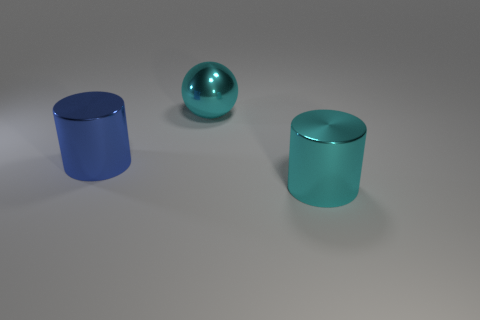Is the number of large shiny spheres in front of the blue metal object less than the number of large yellow matte cylinders?
Your response must be concise. No. Is there anything else that is the same size as the blue metal cylinder?
Keep it short and to the point. Yes. What is the size of the metal cylinder that is left of the metal thing in front of the blue shiny cylinder?
Offer a terse response. Large. Is there anything else that has the same shape as the big blue thing?
Give a very brief answer. Yes. Is the number of metallic cylinders less than the number of blue objects?
Your answer should be very brief. No. What is the object that is right of the large blue shiny cylinder and in front of the big cyan metal ball made of?
Provide a short and direct response. Metal. Is there a shiny ball in front of the cylinder that is to the right of the large shiny sphere?
Your answer should be very brief. No. How many objects are either large metal cylinders or large cyan spheres?
Ensure brevity in your answer.  3. The metal thing that is both in front of the sphere and behind the big cyan metallic cylinder has what shape?
Your response must be concise. Cylinder. Does the big cyan object that is on the left side of the big cyan cylinder have the same material as the large blue thing?
Provide a succinct answer. Yes. 